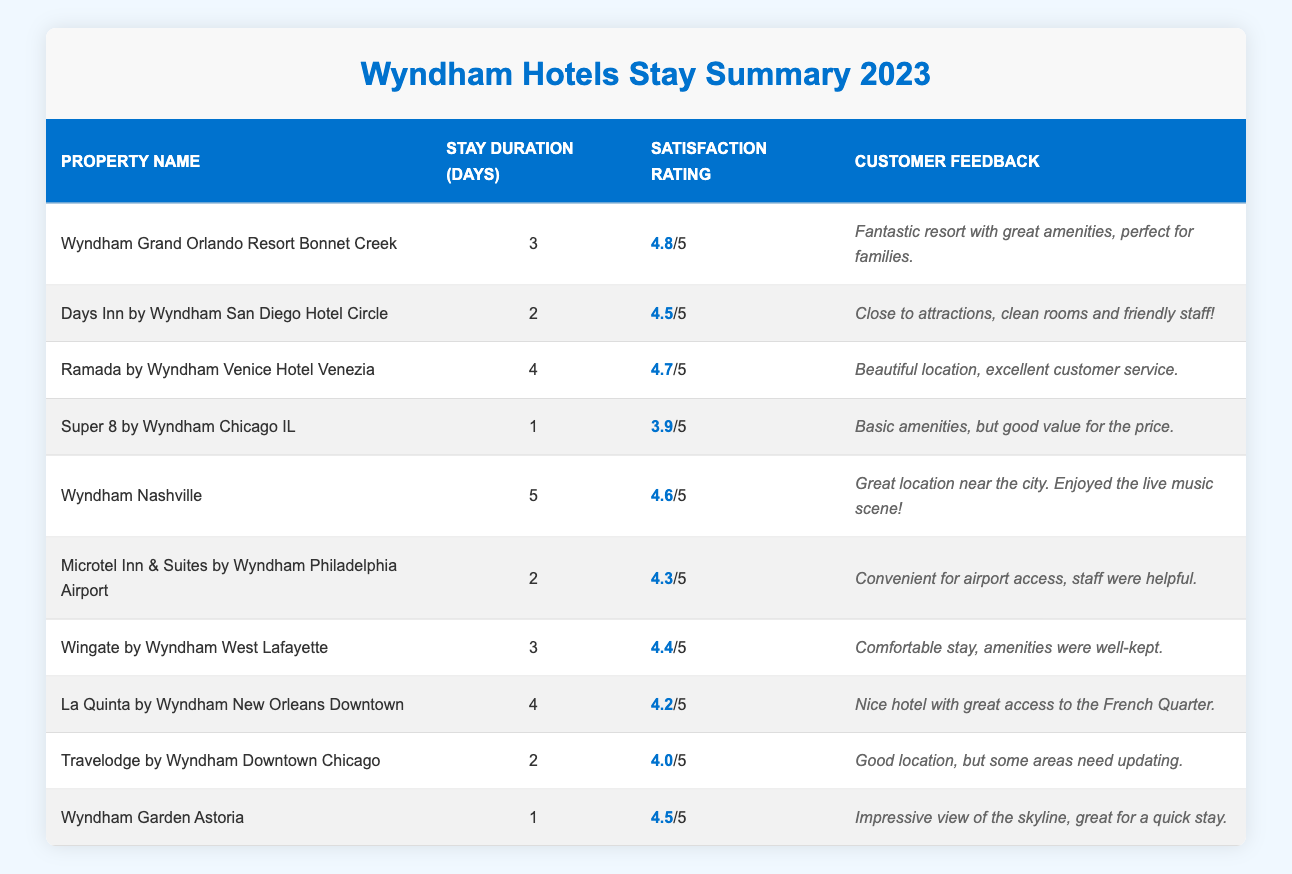What is the customer satisfaction rating for Wyndham Grand Orlando Resort Bonnet Creek? The table lists the customer satisfaction rating for this property as 4.8.
Answer: 4.8 Which hotel has the longest average stay duration? The longest stay duration in the table is 5 days at Wyndham Nashville.
Answer: Wyndham Nashville What is the customer feedback for Ramada by Wyndham Venice Hotel Venezia? According to the table, the feedback states, "Beautiful location, excellent customer service."
Answer: Beautiful location, excellent customer service How many hotels have a customer satisfaction rating of 4.5 or higher? The hotels with ratings of 4.5 or higher are Wyndham Grand Orlando Resort Bonnet Creek, Days Inn by Wyndham San Diego Hotel Circle, Ramada by Wyndham Venice Hotel Venezia, Wyndham Nashville, Wingate by Wyndham West Lafayette, and Wyndham Garden Astoria, totaling 6 hotels.
Answer: 6 What is the average customer satisfaction rating for stays of 2 days? The ratings for stays of 2 days are 4.5 (Days Inn), 4.3 (Microtel Inn), and 4.0 (Travelodge). The average is (4.5 + 4.3 + 4.0) / 3 = 4.2667, rounded to 4.3.
Answer: 4.3 Which property has the lowest customer satisfaction rating, and what is it? The property with the lowest rating is Super 8 by Wyndham Chicago IL, with a rating of 3.9.
Answer: Super 8 by Wyndham Chicago IL, 3.9 Is the duration of stay for Wyndham Nashville greater than the average stay duration for all hotels? The total stay durations are 3, 2, 4, 1, 5, 2, 3, 4, 2, and 1, which sum to 27 days among 10 hotels, giving an average of 2.7 days. Since Wyndham Nashville has a stay of 5 days, it is greater than the average.
Answer: Yes What is the customer satisfaction rating difference between the highest and lowest-rated hotel? The highest rating is 4.8 (Wyndham Grand Orlando Resort Bonnet Creek) and the lowest is 3.9 (Super 8 by Wyndham Chicago IL). The difference is 4.8 - 3.9 = 0.9.
Answer: 0.9 Which hotel is noted for its quick stay with an impressive skyline view? According to the table, Wyndham Garden Astoria is noted for its impressive view of the skyline and suitability for a quick stay.
Answer: Wyndham Garden Astoria What percentage of hotels have a stay duration of 3 days or less? There are 4 hotels with a stay duration of 1 to 3 days (Super 8, Wyndham Garden, Days Inn, and Microtel Inn) out of 10 total hotels. So, the percentage is (4/10) * 100 = 40%.
Answer: 40% How does the feedback for Days Inn by Wyndham San Diego Hotel Circle reflect its customer satisfaction? The feedback stated it is "close to attractions, clean rooms and friendly staff," indicating a positive experience correlating with its 4.5 satisfaction rating.
Answer: Positive experience 